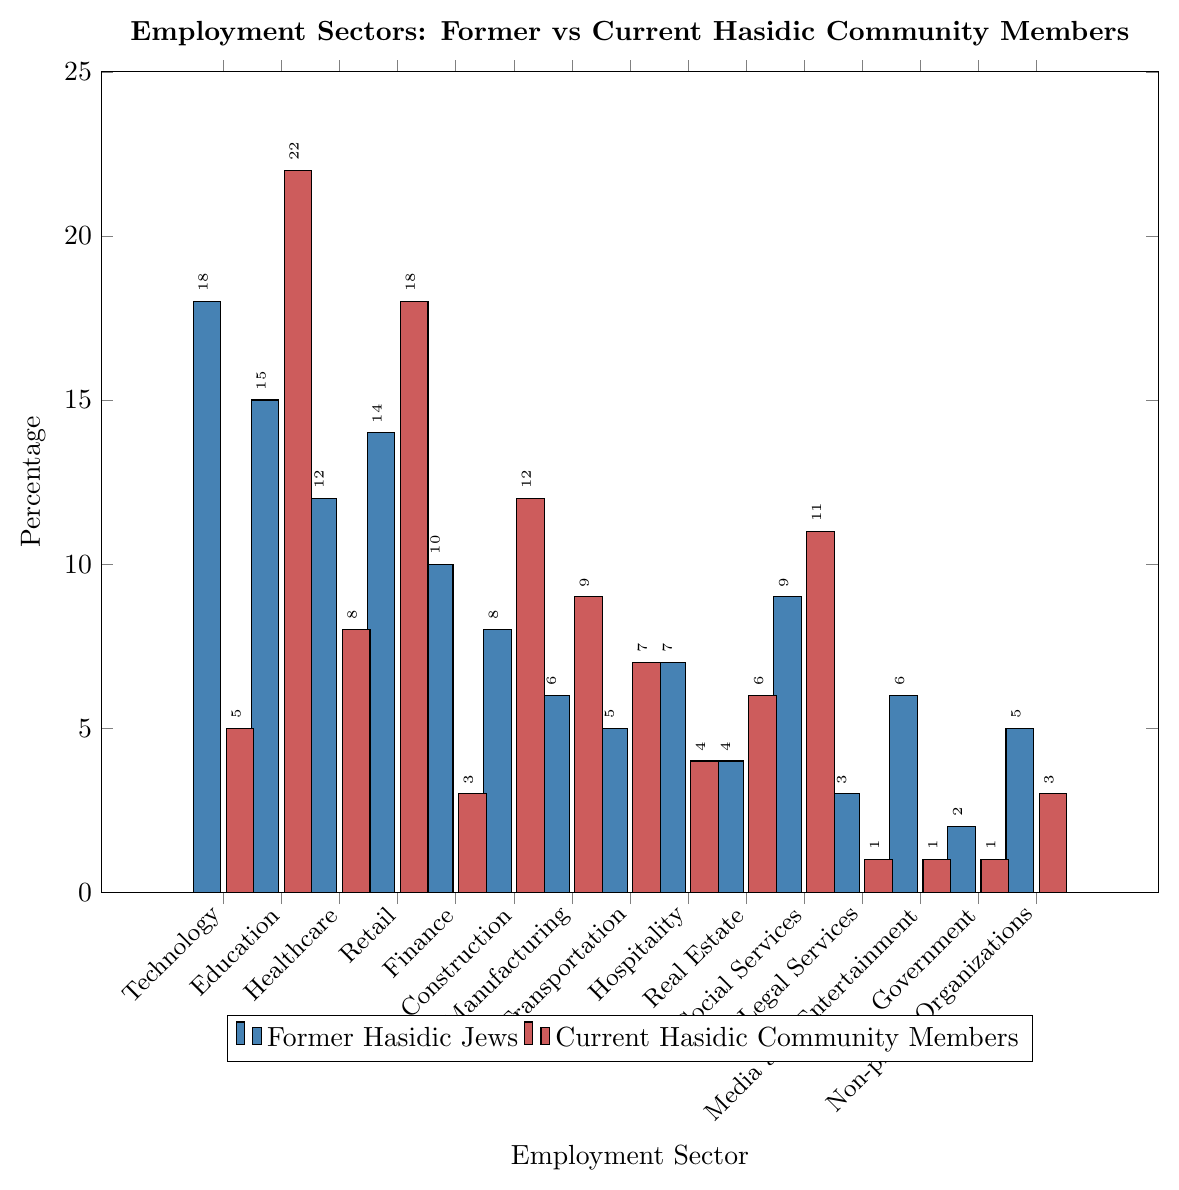Which employment sector has the highest percentage among former Hasidic Jews? The highest percentage bar among former Hasidic Jews is for Technology, which reaches 18%.
Answer: Technology Which employment sector has the highest percentage among current Hasidic community members? The highest percentage bar for current Hasidic community members is for Education, which reaches 22%.
Answer: Education Which employment sectors have a higher percentage of former Hasidic Jews compared to current Hasidic community members? Former Hasidic Jews have higher percentages in Technology (18% vs. 5%), Healthcare (12% vs. 8%), Finance (10% vs. 3%), Legal Services (3% vs. 1%), Media and Entertainment (6% vs. 1%), and Government (2% vs. 1%).
Answer: Technology, Healthcare, Finance, Legal Services, Media and Entertainment, Government Are there any sectors where the percentage is the same for both groups? The bar heights indicate that no employment sector has equal percentages for both groups.
Answer: No What is the combined percentage of former Hasidic Jews working in Technology and Finance sectors? The bar for Technology is 18%, and for Finance is 10%. Adding these gives 18% + 10% = 28%.
Answer: 28% Which group has a higher percentage in Social Services? The bar for Social Services is higher for current Hasidic community members at 11%, compared to 9% for former Hasidic Jews.
Answer: Current Hasidic community members How much greater is the percentage of former Hasidic Jews in Technology than in Manufacturing? The bar for Technology is 18%, and for Manufacturing it is 6%. The difference is 18% - 6% = 12%.
Answer: 12% Compare the percentages in Retail for both groups: which group has a greater percentage and by how much? The bar for Retail is 18% for current Hasidic members and 14% for former Hasidic Jews. The difference is 18% - 14% = 4%.
Answer: Current Hasidic community members by 4% In terms of visual height, which bar is shortest among current Hasidic community members and what percentage does it represent? The shortest bar among current Hasidic community members is for Government, Legal Services, and Media and Entertainment, all at 1%.
Answer: Government, Legal Services, Media and Entertainment at 1% If you exclude the Technology sector, what is the average percentage of former Hasidic Jews in the remaining sectors? Excluding Technology (18%), the remaining percentages are [15, 12, 14, 10, 8, 6, 5, 7, 4, 9, 3, 6, 2, 5]. Summing these gives 106%. There are 14 sectors, so the average is 106/14 ≈ 7.57%.
Answer: 7.57% 